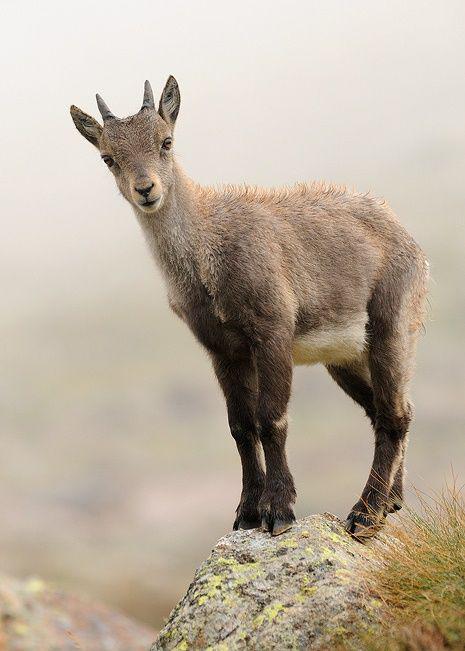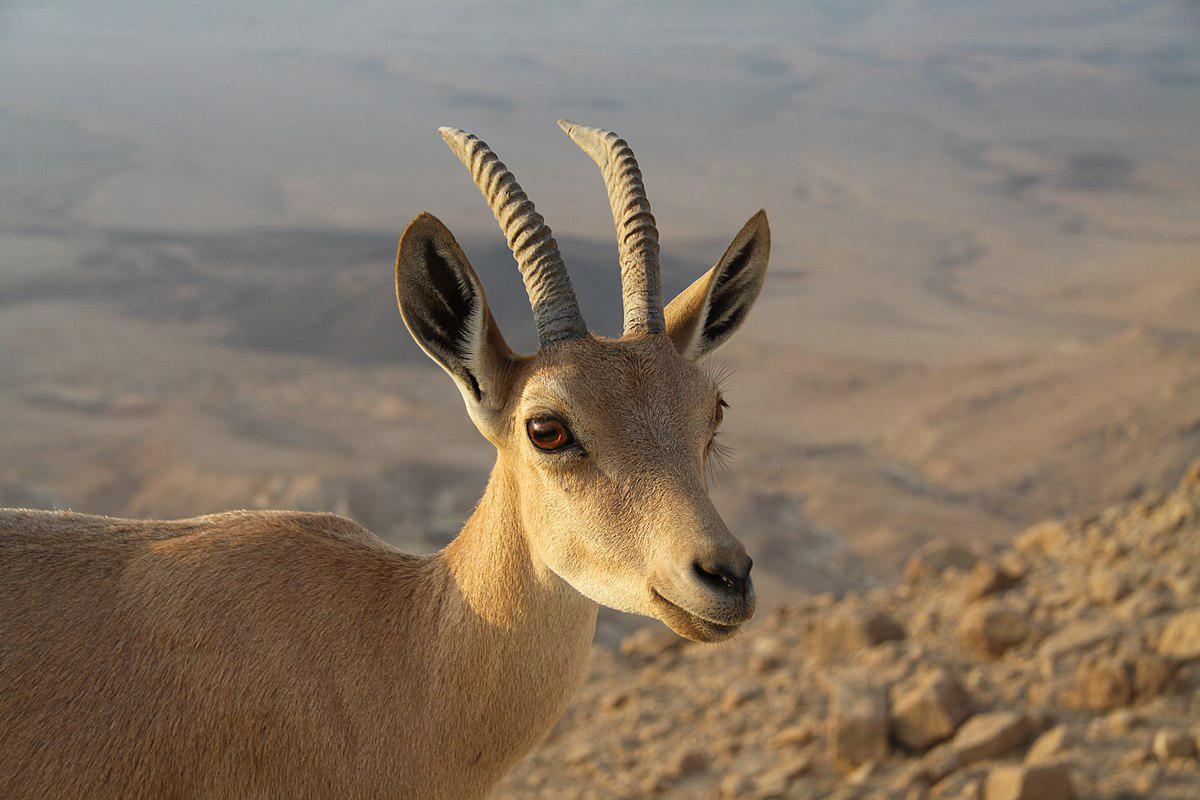The first image is the image on the left, the second image is the image on the right. For the images shown, is this caption "The left image contains exactly two mountain goats." true? Answer yes or no. No. The first image is the image on the left, the second image is the image on the right. Assess this claim about the two images: "There are two animals in the image on the left.". Correct or not? Answer yes or no. No. 